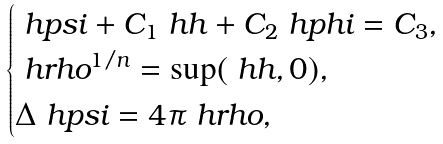Convert formula to latex. <formula><loc_0><loc_0><loc_500><loc_500>\begin{cases} \ h p s i + C _ { 1 } \ h h + C _ { 2 } \ h p h i = C _ { 3 } , \\ \ h r h o ^ { 1 / n } = \sup ( \ h h , 0 ) , \\ \Delta \ h p s i = 4 \pi \ h r h o , \\ \end{cases}</formula> 